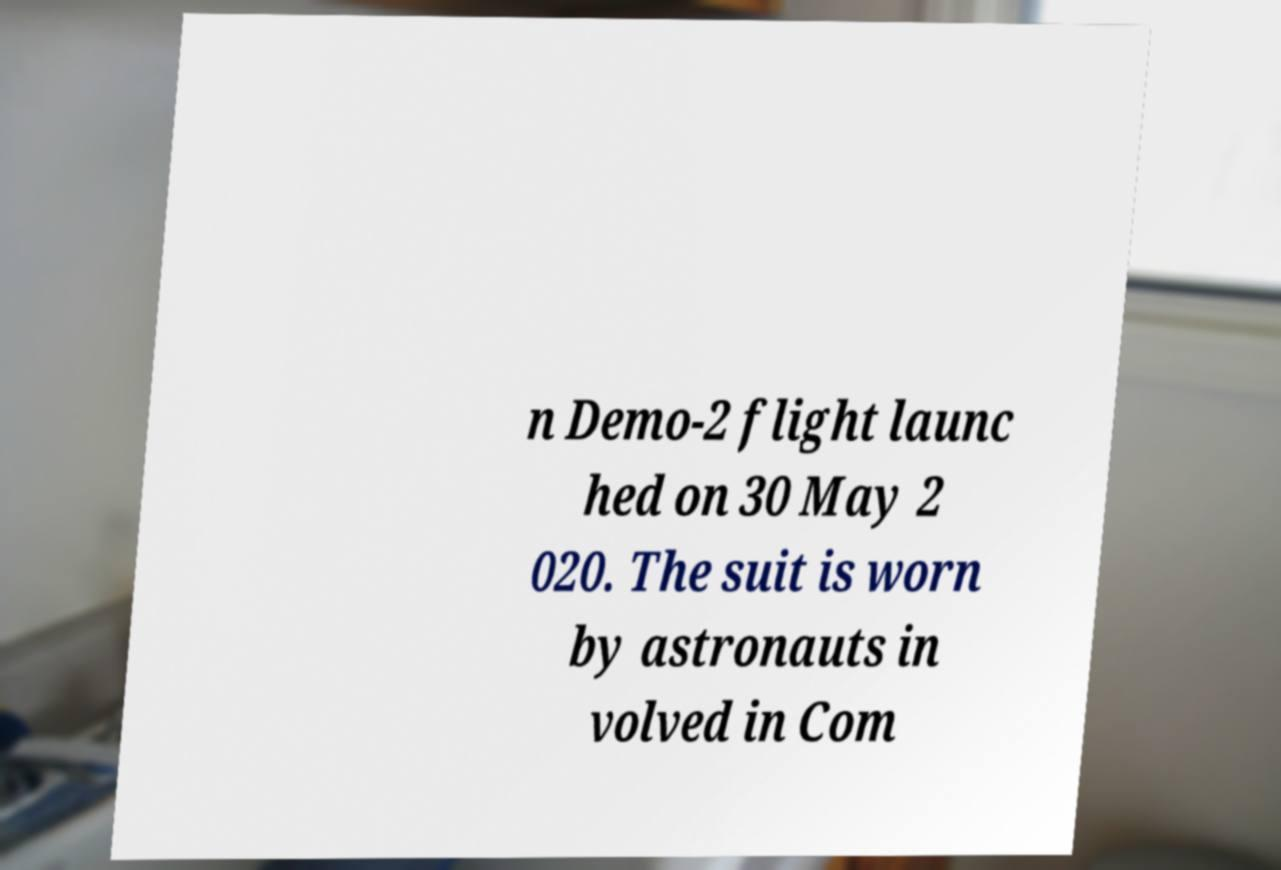I need the written content from this picture converted into text. Can you do that? n Demo-2 flight launc hed on 30 May 2 020. The suit is worn by astronauts in volved in Com 